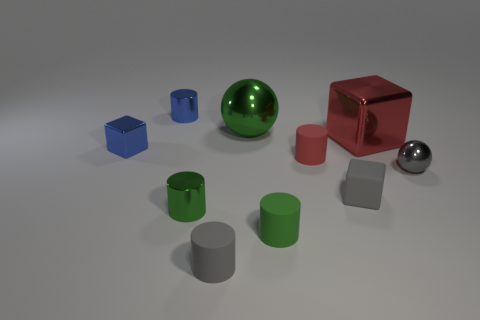Subtract all purple cubes. How many green cylinders are left? 2 Subtract 1 cylinders. How many cylinders are left? 4 Subtract all gray cylinders. How many cylinders are left? 4 Subtract all green cylinders. How many cylinders are left? 3 Subtract all balls. How many objects are left? 8 Subtract all yellow cylinders. Subtract all cyan cubes. How many cylinders are left? 5 Add 2 blue shiny objects. How many blue shiny objects are left? 4 Add 4 large purple cylinders. How many large purple cylinders exist? 4 Subtract 1 gray spheres. How many objects are left? 9 Subtract all small blocks. Subtract all large yellow rubber spheres. How many objects are left? 8 